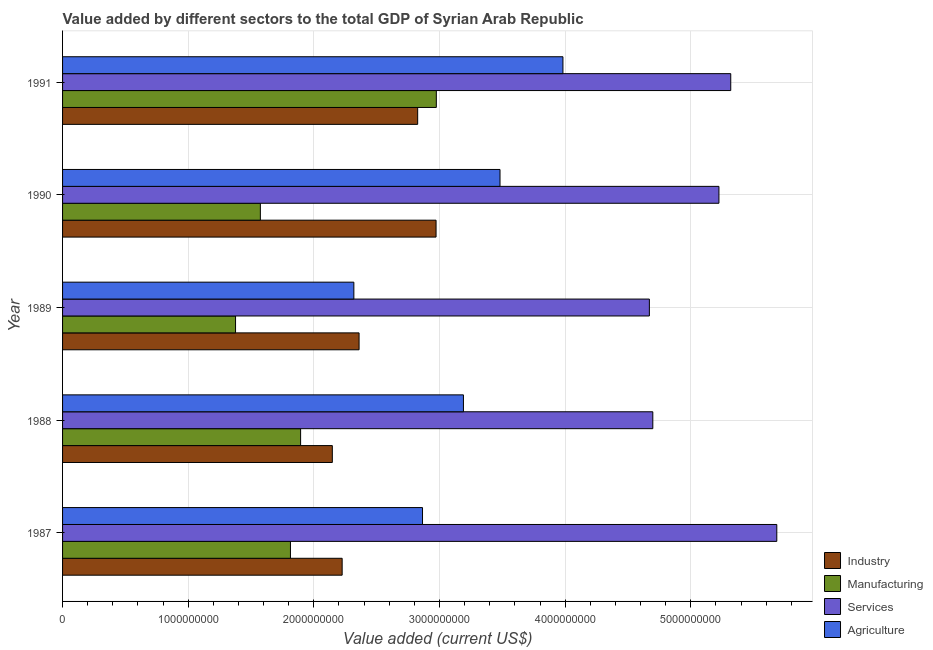Are the number of bars on each tick of the Y-axis equal?
Offer a terse response. Yes. How many bars are there on the 3rd tick from the bottom?
Provide a short and direct response. 4. What is the label of the 1st group of bars from the top?
Offer a terse response. 1991. What is the value added by manufacturing sector in 1990?
Offer a very short reply. 1.57e+09. Across all years, what is the maximum value added by industrial sector?
Give a very brief answer. 2.97e+09. Across all years, what is the minimum value added by agricultural sector?
Offer a terse response. 2.32e+09. In which year was the value added by services sector maximum?
Provide a succinct answer. 1987. What is the total value added by services sector in the graph?
Offer a very short reply. 2.56e+1. What is the difference between the value added by industrial sector in 1988 and that in 1991?
Your answer should be compact. -6.79e+08. What is the difference between the value added by agricultural sector in 1991 and the value added by services sector in 1989?
Ensure brevity in your answer.  -6.88e+08. What is the average value added by manufacturing sector per year?
Your response must be concise. 1.93e+09. In the year 1990, what is the difference between the value added by agricultural sector and value added by industrial sector?
Ensure brevity in your answer.  5.09e+08. In how many years, is the value added by manufacturing sector greater than 4400000000 US$?
Offer a very short reply. 0. What is the ratio of the value added by manufacturing sector in 1987 to that in 1990?
Provide a succinct answer. 1.15. What is the difference between the highest and the second highest value added by industrial sector?
Offer a very short reply. 1.46e+08. What is the difference between the highest and the lowest value added by agricultural sector?
Your answer should be very brief. 1.66e+09. In how many years, is the value added by manufacturing sector greater than the average value added by manufacturing sector taken over all years?
Offer a very short reply. 1. Is the sum of the value added by services sector in 1987 and 1991 greater than the maximum value added by industrial sector across all years?
Keep it short and to the point. Yes. Is it the case that in every year, the sum of the value added by industrial sector and value added by manufacturing sector is greater than the sum of value added by agricultural sector and value added by services sector?
Your answer should be compact. Yes. What does the 4th bar from the top in 1989 represents?
Keep it short and to the point. Industry. What does the 1st bar from the bottom in 1991 represents?
Offer a terse response. Industry. Are all the bars in the graph horizontal?
Keep it short and to the point. Yes. How many years are there in the graph?
Make the answer very short. 5. What is the difference between two consecutive major ticks on the X-axis?
Make the answer very short. 1.00e+09. Where does the legend appear in the graph?
Your answer should be very brief. Bottom right. How are the legend labels stacked?
Offer a very short reply. Vertical. What is the title of the graph?
Your response must be concise. Value added by different sectors to the total GDP of Syrian Arab Republic. Does "Other greenhouse gases" appear as one of the legend labels in the graph?
Give a very brief answer. No. What is the label or title of the X-axis?
Your answer should be very brief. Value added (current US$). What is the Value added (current US$) of Industry in 1987?
Give a very brief answer. 2.23e+09. What is the Value added (current US$) of Manufacturing in 1987?
Your answer should be very brief. 1.81e+09. What is the Value added (current US$) in Services in 1987?
Offer a very short reply. 5.68e+09. What is the Value added (current US$) in Agriculture in 1987?
Provide a succinct answer. 2.86e+09. What is the Value added (current US$) of Industry in 1988?
Keep it short and to the point. 2.15e+09. What is the Value added (current US$) of Manufacturing in 1988?
Your answer should be very brief. 1.89e+09. What is the Value added (current US$) of Services in 1988?
Ensure brevity in your answer.  4.70e+09. What is the Value added (current US$) of Agriculture in 1988?
Offer a very short reply. 3.19e+09. What is the Value added (current US$) of Industry in 1989?
Give a very brief answer. 2.36e+09. What is the Value added (current US$) in Manufacturing in 1989?
Offer a terse response. 1.38e+09. What is the Value added (current US$) of Services in 1989?
Keep it short and to the point. 4.67e+09. What is the Value added (current US$) in Agriculture in 1989?
Make the answer very short. 2.32e+09. What is the Value added (current US$) in Industry in 1990?
Provide a short and direct response. 2.97e+09. What is the Value added (current US$) in Manufacturing in 1990?
Give a very brief answer. 1.57e+09. What is the Value added (current US$) in Services in 1990?
Ensure brevity in your answer.  5.22e+09. What is the Value added (current US$) of Agriculture in 1990?
Your answer should be very brief. 3.48e+09. What is the Value added (current US$) of Industry in 1991?
Ensure brevity in your answer.  2.83e+09. What is the Value added (current US$) in Manufacturing in 1991?
Offer a very short reply. 2.97e+09. What is the Value added (current US$) of Services in 1991?
Offer a very short reply. 5.32e+09. What is the Value added (current US$) in Agriculture in 1991?
Your response must be concise. 3.98e+09. Across all years, what is the maximum Value added (current US$) of Industry?
Provide a short and direct response. 2.97e+09. Across all years, what is the maximum Value added (current US$) in Manufacturing?
Your response must be concise. 2.97e+09. Across all years, what is the maximum Value added (current US$) of Services?
Provide a short and direct response. 5.68e+09. Across all years, what is the maximum Value added (current US$) of Agriculture?
Offer a terse response. 3.98e+09. Across all years, what is the minimum Value added (current US$) of Industry?
Make the answer very short. 2.15e+09. Across all years, what is the minimum Value added (current US$) in Manufacturing?
Your answer should be compact. 1.38e+09. Across all years, what is the minimum Value added (current US$) of Services?
Your response must be concise. 4.67e+09. Across all years, what is the minimum Value added (current US$) of Agriculture?
Your answer should be compact. 2.32e+09. What is the total Value added (current US$) of Industry in the graph?
Your answer should be very brief. 1.25e+1. What is the total Value added (current US$) in Manufacturing in the graph?
Give a very brief answer. 9.63e+09. What is the total Value added (current US$) of Services in the graph?
Provide a short and direct response. 2.56e+1. What is the total Value added (current US$) in Agriculture in the graph?
Keep it short and to the point. 1.58e+1. What is the difference between the Value added (current US$) of Industry in 1987 and that in 1988?
Keep it short and to the point. 7.82e+07. What is the difference between the Value added (current US$) of Manufacturing in 1987 and that in 1988?
Give a very brief answer. -8.08e+07. What is the difference between the Value added (current US$) of Services in 1987 and that in 1988?
Offer a very short reply. 9.87e+08. What is the difference between the Value added (current US$) in Agriculture in 1987 and that in 1988?
Offer a terse response. -3.26e+08. What is the difference between the Value added (current US$) of Industry in 1987 and that in 1989?
Ensure brevity in your answer.  -1.35e+08. What is the difference between the Value added (current US$) of Manufacturing in 1987 and that in 1989?
Ensure brevity in your answer.  4.37e+08. What is the difference between the Value added (current US$) in Services in 1987 and that in 1989?
Your response must be concise. 1.01e+09. What is the difference between the Value added (current US$) of Agriculture in 1987 and that in 1989?
Provide a short and direct response. 5.46e+08. What is the difference between the Value added (current US$) in Industry in 1987 and that in 1990?
Make the answer very short. -7.47e+08. What is the difference between the Value added (current US$) of Manufacturing in 1987 and that in 1990?
Your answer should be compact. 2.40e+08. What is the difference between the Value added (current US$) of Services in 1987 and that in 1990?
Offer a terse response. 4.61e+08. What is the difference between the Value added (current US$) in Agriculture in 1987 and that in 1990?
Provide a succinct answer. -6.17e+08. What is the difference between the Value added (current US$) in Industry in 1987 and that in 1991?
Keep it short and to the point. -6.01e+08. What is the difference between the Value added (current US$) in Manufacturing in 1987 and that in 1991?
Provide a succinct answer. -1.16e+09. What is the difference between the Value added (current US$) of Services in 1987 and that in 1991?
Keep it short and to the point. 3.67e+08. What is the difference between the Value added (current US$) in Agriculture in 1987 and that in 1991?
Your response must be concise. -1.12e+09. What is the difference between the Value added (current US$) in Industry in 1988 and that in 1989?
Your answer should be compact. -2.13e+08. What is the difference between the Value added (current US$) of Manufacturing in 1988 and that in 1989?
Give a very brief answer. 5.18e+08. What is the difference between the Value added (current US$) in Services in 1988 and that in 1989?
Your response must be concise. 2.74e+07. What is the difference between the Value added (current US$) of Agriculture in 1988 and that in 1989?
Keep it short and to the point. 8.72e+08. What is the difference between the Value added (current US$) in Industry in 1988 and that in 1990?
Give a very brief answer. -8.26e+08. What is the difference between the Value added (current US$) in Manufacturing in 1988 and that in 1990?
Make the answer very short. 3.20e+08. What is the difference between the Value added (current US$) of Services in 1988 and that in 1990?
Offer a very short reply. -5.26e+08. What is the difference between the Value added (current US$) of Agriculture in 1988 and that in 1990?
Offer a terse response. -2.91e+08. What is the difference between the Value added (current US$) in Industry in 1988 and that in 1991?
Your response must be concise. -6.79e+08. What is the difference between the Value added (current US$) in Manufacturing in 1988 and that in 1991?
Make the answer very short. -1.08e+09. What is the difference between the Value added (current US$) of Services in 1988 and that in 1991?
Ensure brevity in your answer.  -6.20e+08. What is the difference between the Value added (current US$) of Agriculture in 1988 and that in 1991?
Make the answer very short. -7.92e+08. What is the difference between the Value added (current US$) in Industry in 1989 and that in 1990?
Your answer should be compact. -6.13e+08. What is the difference between the Value added (current US$) in Manufacturing in 1989 and that in 1990?
Provide a short and direct response. -1.97e+08. What is the difference between the Value added (current US$) in Services in 1989 and that in 1990?
Offer a terse response. -5.54e+08. What is the difference between the Value added (current US$) in Agriculture in 1989 and that in 1990?
Your answer should be compact. -1.16e+09. What is the difference between the Value added (current US$) of Industry in 1989 and that in 1991?
Offer a terse response. -4.66e+08. What is the difference between the Value added (current US$) of Manufacturing in 1989 and that in 1991?
Your answer should be very brief. -1.60e+09. What is the difference between the Value added (current US$) in Services in 1989 and that in 1991?
Offer a very short reply. -6.48e+08. What is the difference between the Value added (current US$) in Agriculture in 1989 and that in 1991?
Ensure brevity in your answer.  -1.66e+09. What is the difference between the Value added (current US$) of Industry in 1990 and that in 1991?
Your answer should be very brief. 1.46e+08. What is the difference between the Value added (current US$) of Manufacturing in 1990 and that in 1991?
Give a very brief answer. -1.40e+09. What is the difference between the Value added (current US$) of Services in 1990 and that in 1991?
Your response must be concise. -9.40e+07. What is the difference between the Value added (current US$) of Agriculture in 1990 and that in 1991?
Your answer should be compact. -5.01e+08. What is the difference between the Value added (current US$) in Industry in 1987 and the Value added (current US$) in Manufacturing in 1988?
Make the answer very short. 3.31e+08. What is the difference between the Value added (current US$) of Industry in 1987 and the Value added (current US$) of Services in 1988?
Make the answer very short. -2.47e+09. What is the difference between the Value added (current US$) in Industry in 1987 and the Value added (current US$) in Agriculture in 1988?
Keep it short and to the point. -9.65e+08. What is the difference between the Value added (current US$) in Manufacturing in 1987 and the Value added (current US$) in Services in 1988?
Offer a terse response. -2.88e+09. What is the difference between the Value added (current US$) in Manufacturing in 1987 and the Value added (current US$) in Agriculture in 1988?
Offer a terse response. -1.38e+09. What is the difference between the Value added (current US$) in Services in 1987 and the Value added (current US$) in Agriculture in 1988?
Ensure brevity in your answer.  2.49e+09. What is the difference between the Value added (current US$) in Industry in 1987 and the Value added (current US$) in Manufacturing in 1989?
Your response must be concise. 8.48e+08. What is the difference between the Value added (current US$) in Industry in 1987 and the Value added (current US$) in Services in 1989?
Give a very brief answer. -2.45e+09. What is the difference between the Value added (current US$) of Industry in 1987 and the Value added (current US$) of Agriculture in 1989?
Give a very brief answer. -9.32e+07. What is the difference between the Value added (current US$) of Manufacturing in 1987 and the Value added (current US$) of Services in 1989?
Offer a terse response. -2.86e+09. What is the difference between the Value added (current US$) in Manufacturing in 1987 and the Value added (current US$) in Agriculture in 1989?
Provide a succinct answer. -5.05e+08. What is the difference between the Value added (current US$) of Services in 1987 and the Value added (current US$) of Agriculture in 1989?
Ensure brevity in your answer.  3.37e+09. What is the difference between the Value added (current US$) in Industry in 1987 and the Value added (current US$) in Manufacturing in 1990?
Provide a short and direct response. 6.51e+08. What is the difference between the Value added (current US$) of Industry in 1987 and the Value added (current US$) of Services in 1990?
Provide a succinct answer. -3.00e+09. What is the difference between the Value added (current US$) of Industry in 1987 and the Value added (current US$) of Agriculture in 1990?
Provide a short and direct response. -1.26e+09. What is the difference between the Value added (current US$) in Manufacturing in 1987 and the Value added (current US$) in Services in 1990?
Your answer should be very brief. -3.41e+09. What is the difference between the Value added (current US$) of Manufacturing in 1987 and the Value added (current US$) of Agriculture in 1990?
Your answer should be very brief. -1.67e+09. What is the difference between the Value added (current US$) in Services in 1987 and the Value added (current US$) in Agriculture in 1990?
Your answer should be very brief. 2.20e+09. What is the difference between the Value added (current US$) of Industry in 1987 and the Value added (current US$) of Manufacturing in 1991?
Make the answer very short. -7.50e+08. What is the difference between the Value added (current US$) of Industry in 1987 and the Value added (current US$) of Services in 1991?
Provide a succinct answer. -3.09e+09. What is the difference between the Value added (current US$) of Industry in 1987 and the Value added (current US$) of Agriculture in 1991?
Give a very brief answer. -1.76e+09. What is the difference between the Value added (current US$) in Manufacturing in 1987 and the Value added (current US$) in Services in 1991?
Your answer should be very brief. -3.50e+09. What is the difference between the Value added (current US$) of Manufacturing in 1987 and the Value added (current US$) of Agriculture in 1991?
Your answer should be very brief. -2.17e+09. What is the difference between the Value added (current US$) in Services in 1987 and the Value added (current US$) in Agriculture in 1991?
Your response must be concise. 1.70e+09. What is the difference between the Value added (current US$) of Industry in 1988 and the Value added (current US$) of Manufacturing in 1989?
Offer a terse response. 7.70e+08. What is the difference between the Value added (current US$) of Industry in 1988 and the Value added (current US$) of Services in 1989?
Make the answer very short. -2.52e+09. What is the difference between the Value added (current US$) of Industry in 1988 and the Value added (current US$) of Agriculture in 1989?
Ensure brevity in your answer.  -1.71e+08. What is the difference between the Value added (current US$) of Manufacturing in 1988 and the Value added (current US$) of Services in 1989?
Offer a terse response. -2.78e+09. What is the difference between the Value added (current US$) in Manufacturing in 1988 and the Value added (current US$) in Agriculture in 1989?
Provide a short and direct response. -4.24e+08. What is the difference between the Value added (current US$) in Services in 1988 and the Value added (current US$) in Agriculture in 1989?
Give a very brief answer. 2.38e+09. What is the difference between the Value added (current US$) in Industry in 1988 and the Value added (current US$) in Manufacturing in 1990?
Your answer should be very brief. 5.73e+08. What is the difference between the Value added (current US$) in Industry in 1988 and the Value added (current US$) in Services in 1990?
Your answer should be very brief. -3.08e+09. What is the difference between the Value added (current US$) of Industry in 1988 and the Value added (current US$) of Agriculture in 1990?
Make the answer very short. -1.33e+09. What is the difference between the Value added (current US$) in Manufacturing in 1988 and the Value added (current US$) in Services in 1990?
Make the answer very short. -3.33e+09. What is the difference between the Value added (current US$) of Manufacturing in 1988 and the Value added (current US$) of Agriculture in 1990?
Offer a terse response. -1.59e+09. What is the difference between the Value added (current US$) in Services in 1988 and the Value added (current US$) in Agriculture in 1990?
Ensure brevity in your answer.  1.22e+09. What is the difference between the Value added (current US$) in Industry in 1988 and the Value added (current US$) in Manufacturing in 1991?
Provide a short and direct response. -8.28e+08. What is the difference between the Value added (current US$) of Industry in 1988 and the Value added (current US$) of Services in 1991?
Offer a very short reply. -3.17e+09. What is the difference between the Value added (current US$) in Industry in 1988 and the Value added (current US$) in Agriculture in 1991?
Your answer should be compact. -1.84e+09. What is the difference between the Value added (current US$) in Manufacturing in 1988 and the Value added (current US$) in Services in 1991?
Your answer should be very brief. -3.42e+09. What is the difference between the Value added (current US$) of Manufacturing in 1988 and the Value added (current US$) of Agriculture in 1991?
Your answer should be compact. -2.09e+09. What is the difference between the Value added (current US$) of Services in 1988 and the Value added (current US$) of Agriculture in 1991?
Provide a succinct answer. 7.15e+08. What is the difference between the Value added (current US$) in Industry in 1989 and the Value added (current US$) in Manufacturing in 1990?
Ensure brevity in your answer.  7.86e+08. What is the difference between the Value added (current US$) in Industry in 1989 and the Value added (current US$) in Services in 1990?
Ensure brevity in your answer.  -2.86e+09. What is the difference between the Value added (current US$) of Industry in 1989 and the Value added (current US$) of Agriculture in 1990?
Make the answer very short. -1.12e+09. What is the difference between the Value added (current US$) in Manufacturing in 1989 and the Value added (current US$) in Services in 1990?
Your answer should be very brief. -3.85e+09. What is the difference between the Value added (current US$) in Manufacturing in 1989 and the Value added (current US$) in Agriculture in 1990?
Give a very brief answer. -2.10e+09. What is the difference between the Value added (current US$) in Services in 1989 and the Value added (current US$) in Agriculture in 1990?
Your answer should be compact. 1.19e+09. What is the difference between the Value added (current US$) in Industry in 1989 and the Value added (current US$) in Manufacturing in 1991?
Offer a terse response. -6.15e+08. What is the difference between the Value added (current US$) in Industry in 1989 and the Value added (current US$) in Services in 1991?
Ensure brevity in your answer.  -2.96e+09. What is the difference between the Value added (current US$) of Industry in 1989 and the Value added (current US$) of Agriculture in 1991?
Offer a terse response. -1.62e+09. What is the difference between the Value added (current US$) of Manufacturing in 1989 and the Value added (current US$) of Services in 1991?
Provide a short and direct response. -3.94e+09. What is the difference between the Value added (current US$) in Manufacturing in 1989 and the Value added (current US$) in Agriculture in 1991?
Ensure brevity in your answer.  -2.61e+09. What is the difference between the Value added (current US$) of Services in 1989 and the Value added (current US$) of Agriculture in 1991?
Offer a terse response. 6.88e+08. What is the difference between the Value added (current US$) in Industry in 1990 and the Value added (current US$) in Manufacturing in 1991?
Offer a terse response. -2.12e+06. What is the difference between the Value added (current US$) of Industry in 1990 and the Value added (current US$) of Services in 1991?
Offer a terse response. -2.35e+09. What is the difference between the Value added (current US$) in Industry in 1990 and the Value added (current US$) in Agriculture in 1991?
Your answer should be very brief. -1.01e+09. What is the difference between the Value added (current US$) of Manufacturing in 1990 and the Value added (current US$) of Services in 1991?
Ensure brevity in your answer.  -3.74e+09. What is the difference between the Value added (current US$) in Manufacturing in 1990 and the Value added (current US$) in Agriculture in 1991?
Give a very brief answer. -2.41e+09. What is the difference between the Value added (current US$) of Services in 1990 and the Value added (current US$) of Agriculture in 1991?
Ensure brevity in your answer.  1.24e+09. What is the average Value added (current US$) in Industry per year?
Ensure brevity in your answer.  2.51e+09. What is the average Value added (current US$) in Manufacturing per year?
Make the answer very short. 1.93e+09. What is the average Value added (current US$) of Services per year?
Give a very brief answer. 5.12e+09. What is the average Value added (current US$) of Agriculture per year?
Ensure brevity in your answer.  3.17e+09. In the year 1987, what is the difference between the Value added (current US$) of Industry and Value added (current US$) of Manufacturing?
Offer a terse response. 4.11e+08. In the year 1987, what is the difference between the Value added (current US$) of Industry and Value added (current US$) of Services?
Offer a terse response. -3.46e+09. In the year 1987, what is the difference between the Value added (current US$) of Industry and Value added (current US$) of Agriculture?
Offer a very short reply. -6.40e+08. In the year 1987, what is the difference between the Value added (current US$) in Manufacturing and Value added (current US$) in Services?
Your answer should be compact. -3.87e+09. In the year 1987, what is the difference between the Value added (current US$) of Manufacturing and Value added (current US$) of Agriculture?
Provide a short and direct response. -1.05e+09. In the year 1987, what is the difference between the Value added (current US$) of Services and Value added (current US$) of Agriculture?
Offer a very short reply. 2.82e+09. In the year 1988, what is the difference between the Value added (current US$) in Industry and Value added (current US$) in Manufacturing?
Your response must be concise. 2.52e+08. In the year 1988, what is the difference between the Value added (current US$) in Industry and Value added (current US$) in Services?
Keep it short and to the point. -2.55e+09. In the year 1988, what is the difference between the Value added (current US$) in Industry and Value added (current US$) in Agriculture?
Offer a terse response. -1.04e+09. In the year 1988, what is the difference between the Value added (current US$) in Manufacturing and Value added (current US$) in Services?
Offer a very short reply. -2.80e+09. In the year 1988, what is the difference between the Value added (current US$) of Manufacturing and Value added (current US$) of Agriculture?
Your answer should be very brief. -1.30e+09. In the year 1988, what is the difference between the Value added (current US$) in Services and Value added (current US$) in Agriculture?
Your answer should be compact. 1.51e+09. In the year 1989, what is the difference between the Value added (current US$) of Industry and Value added (current US$) of Manufacturing?
Provide a short and direct response. 9.83e+08. In the year 1989, what is the difference between the Value added (current US$) in Industry and Value added (current US$) in Services?
Your response must be concise. -2.31e+09. In the year 1989, what is the difference between the Value added (current US$) in Industry and Value added (current US$) in Agriculture?
Your answer should be compact. 4.16e+07. In the year 1989, what is the difference between the Value added (current US$) in Manufacturing and Value added (current US$) in Services?
Offer a terse response. -3.29e+09. In the year 1989, what is the difference between the Value added (current US$) in Manufacturing and Value added (current US$) in Agriculture?
Your answer should be very brief. -9.42e+08. In the year 1989, what is the difference between the Value added (current US$) in Services and Value added (current US$) in Agriculture?
Your response must be concise. 2.35e+09. In the year 1990, what is the difference between the Value added (current US$) in Industry and Value added (current US$) in Manufacturing?
Provide a short and direct response. 1.40e+09. In the year 1990, what is the difference between the Value added (current US$) of Industry and Value added (current US$) of Services?
Your answer should be very brief. -2.25e+09. In the year 1990, what is the difference between the Value added (current US$) of Industry and Value added (current US$) of Agriculture?
Your response must be concise. -5.09e+08. In the year 1990, what is the difference between the Value added (current US$) in Manufacturing and Value added (current US$) in Services?
Give a very brief answer. -3.65e+09. In the year 1990, what is the difference between the Value added (current US$) of Manufacturing and Value added (current US$) of Agriculture?
Give a very brief answer. -1.91e+09. In the year 1990, what is the difference between the Value added (current US$) in Services and Value added (current US$) in Agriculture?
Your answer should be very brief. 1.74e+09. In the year 1991, what is the difference between the Value added (current US$) in Industry and Value added (current US$) in Manufacturing?
Offer a terse response. -1.49e+08. In the year 1991, what is the difference between the Value added (current US$) in Industry and Value added (current US$) in Services?
Make the answer very short. -2.49e+09. In the year 1991, what is the difference between the Value added (current US$) in Industry and Value added (current US$) in Agriculture?
Make the answer very short. -1.16e+09. In the year 1991, what is the difference between the Value added (current US$) in Manufacturing and Value added (current US$) in Services?
Keep it short and to the point. -2.34e+09. In the year 1991, what is the difference between the Value added (current US$) of Manufacturing and Value added (current US$) of Agriculture?
Give a very brief answer. -1.01e+09. In the year 1991, what is the difference between the Value added (current US$) of Services and Value added (current US$) of Agriculture?
Give a very brief answer. 1.34e+09. What is the ratio of the Value added (current US$) of Industry in 1987 to that in 1988?
Ensure brevity in your answer.  1.04. What is the ratio of the Value added (current US$) in Manufacturing in 1987 to that in 1988?
Provide a short and direct response. 0.96. What is the ratio of the Value added (current US$) of Services in 1987 to that in 1988?
Provide a succinct answer. 1.21. What is the ratio of the Value added (current US$) of Agriculture in 1987 to that in 1988?
Your answer should be compact. 0.9. What is the ratio of the Value added (current US$) of Industry in 1987 to that in 1989?
Give a very brief answer. 0.94. What is the ratio of the Value added (current US$) in Manufacturing in 1987 to that in 1989?
Keep it short and to the point. 1.32. What is the ratio of the Value added (current US$) of Services in 1987 to that in 1989?
Keep it short and to the point. 1.22. What is the ratio of the Value added (current US$) in Agriculture in 1987 to that in 1989?
Your answer should be compact. 1.24. What is the ratio of the Value added (current US$) in Industry in 1987 to that in 1990?
Your answer should be compact. 0.75. What is the ratio of the Value added (current US$) in Manufacturing in 1987 to that in 1990?
Provide a succinct answer. 1.15. What is the ratio of the Value added (current US$) in Services in 1987 to that in 1990?
Ensure brevity in your answer.  1.09. What is the ratio of the Value added (current US$) in Agriculture in 1987 to that in 1990?
Your answer should be very brief. 0.82. What is the ratio of the Value added (current US$) in Industry in 1987 to that in 1991?
Ensure brevity in your answer.  0.79. What is the ratio of the Value added (current US$) in Manufacturing in 1987 to that in 1991?
Offer a terse response. 0.61. What is the ratio of the Value added (current US$) in Services in 1987 to that in 1991?
Your answer should be compact. 1.07. What is the ratio of the Value added (current US$) of Agriculture in 1987 to that in 1991?
Provide a short and direct response. 0.72. What is the ratio of the Value added (current US$) of Industry in 1988 to that in 1989?
Your answer should be compact. 0.91. What is the ratio of the Value added (current US$) in Manufacturing in 1988 to that in 1989?
Ensure brevity in your answer.  1.38. What is the ratio of the Value added (current US$) of Services in 1988 to that in 1989?
Make the answer very short. 1.01. What is the ratio of the Value added (current US$) of Agriculture in 1988 to that in 1989?
Keep it short and to the point. 1.38. What is the ratio of the Value added (current US$) in Industry in 1988 to that in 1990?
Your response must be concise. 0.72. What is the ratio of the Value added (current US$) in Manufacturing in 1988 to that in 1990?
Make the answer very short. 1.2. What is the ratio of the Value added (current US$) in Services in 1988 to that in 1990?
Your response must be concise. 0.9. What is the ratio of the Value added (current US$) in Agriculture in 1988 to that in 1990?
Make the answer very short. 0.92. What is the ratio of the Value added (current US$) of Industry in 1988 to that in 1991?
Ensure brevity in your answer.  0.76. What is the ratio of the Value added (current US$) of Manufacturing in 1988 to that in 1991?
Provide a short and direct response. 0.64. What is the ratio of the Value added (current US$) in Services in 1988 to that in 1991?
Provide a succinct answer. 0.88. What is the ratio of the Value added (current US$) of Agriculture in 1988 to that in 1991?
Ensure brevity in your answer.  0.8. What is the ratio of the Value added (current US$) of Industry in 1989 to that in 1990?
Your response must be concise. 0.79. What is the ratio of the Value added (current US$) of Manufacturing in 1989 to that in 1990?
Provide a succinct answer. 0.87. What is the ratio of the Value added (current US$) in Services in 1989 to that in 1990?
Offer a terse response. 0.89. What is the ratio of the Value added (current US$) of Agriculture in 1989 to that in 1990?
Give a very brief answer. 0.67. What is the ratio of the Value added (current US$) of Industry in 1989 to that in 1991?
Offer a very short reply. 0.83. What is the ratio of the Value added (current US$) of Manufacturing in 1989 to that in 1991?
Offer a very short reply. 0.46. What is the ratio of the Value added (current US$) of Services in 1989 to that in 1991?
Make the answer very short. 0.88. What is the ratio of the Value added (current US$) of Agriculture in 1989 to that in 1991?
Your response must be concise. 0.58. What is the ratio of the Value added (current US$) in Industry in 1990 to that in 1991?
Your answer should be very brief. 1.05. What is the ratio of the Value added (current US$) of Manufacturing in 1990 to that in 1991?
Keep it short and to the point. 0.53. What is the ratio of the Value added (current US$) in Services in 1990 to that in 1991?
Your answer should be compact. 0.98. What is the ratio of the Value added (current US$) of Agriculture in 1990 to that in 1991?
Give a very brief answer. 0.87. What is the difference between the highest and the second highest Value added (current US$) in Industry?
Your answer should be compact. 1.46e+08. What is the difference between the highest and the second highest Value added (current US$) in Manufacturing?
Offer a very short reply. 1.08e+09. What is the difference between the highest and the second highest Value added (current US$) of Services?
Your response must be concise. 3.67e+08. What is the difference between the highest and the second highest Value added (current US$) of Agriculture?
Ensure brevity in your answer.  5.01e+08. What is the difference between the highest and the lowest Value added (current US$) of Industry?
Offer a terse response. 8.26e+08. What is the difference between the highest and the lowest Value added (current US$) in Manufacturing?
Your response must be concise. 1.60e+09. What is the difference between the highest and the lowest Value added (current US$) of Services?
Keep it short and to the point. 1.01e+09. What is the difference between the highest and the lowest Value added (current US$) of Agriculture?
Your response must be concise. 1.66e+09. 